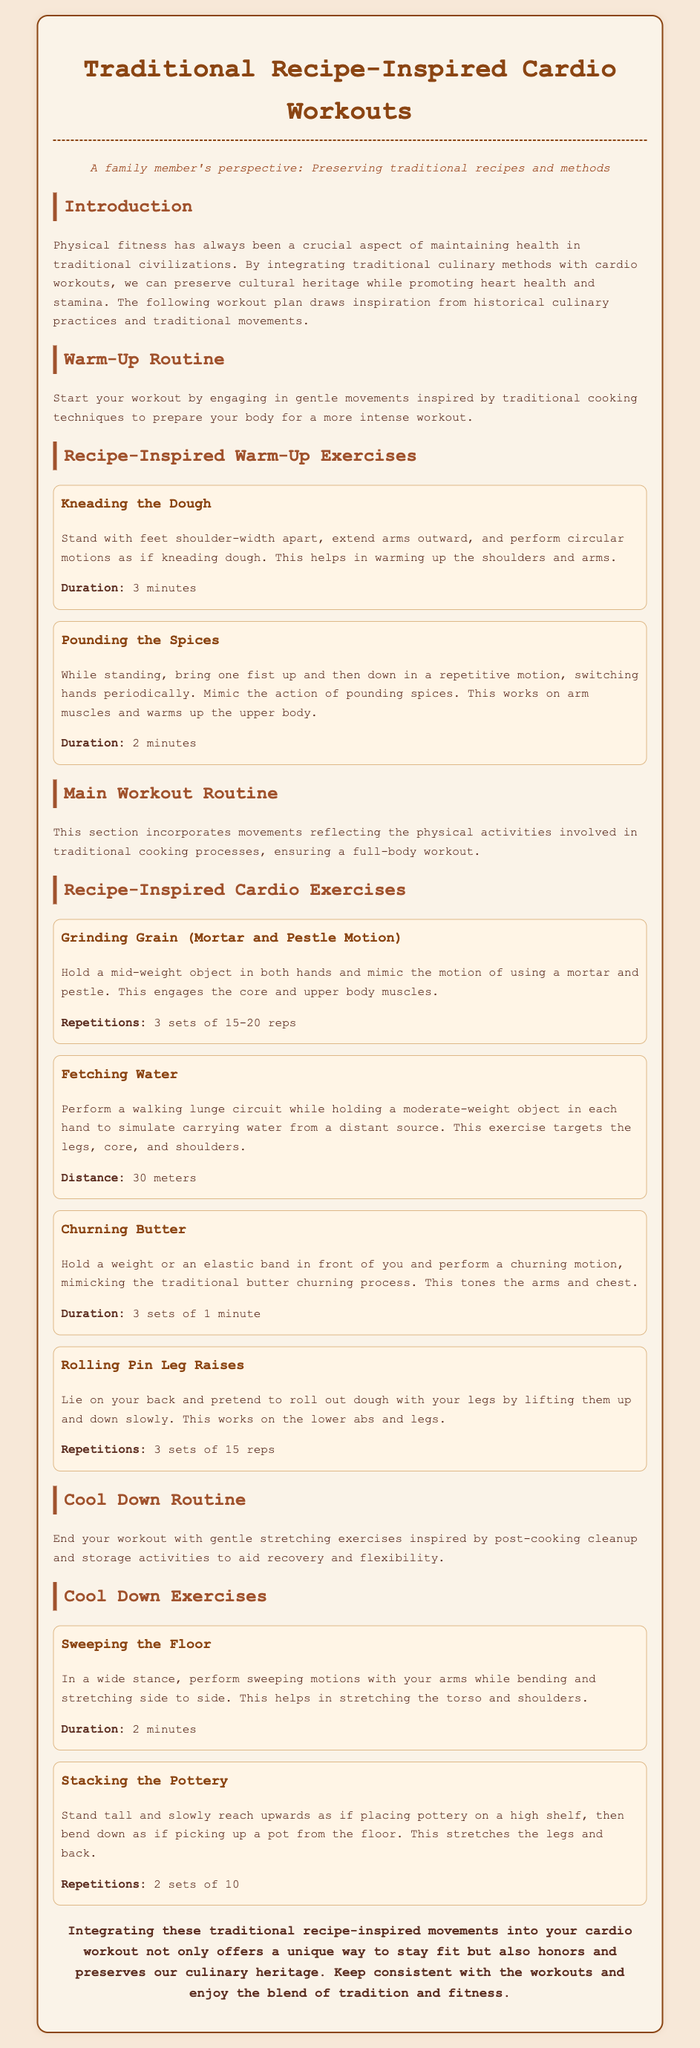What is the title of the document? The title is prominently displayed at the top of the document, indicating the main topic.
Answer: Traditional Recipe-Inspired Cardio Workouts How long should the "Kneading the Dough" exercise be performed? The duration of this exercise is specifically mentioned under its description.
Answer: 3 minutes What is the main focus of this workout plan? The introduction explains the purpose and focus of the workout plan reflecting traditional practices.
Answer: Preserving cultural heritage while promoting heart health What exercise involves mimicking the action of using a mortar and pestle? The document provides specific names for each exercise that relate to cooking activities.
Answer: Grinding Grain (Mortar and Pestle Motion) How many repetitions are suggested for the "Rolling Pin Leg Raises"? The number of repetitions is detailed in the main workout routine for this exercise.
Answer: 3 sets of 15 reps What is the duration for the "Sweeping the Floor" cool down exercise? The duration is indicated specifically within the cool down exercises section of the document.
Answer: 2 minutes What action does the "Fetching Water" exercise simulate? The description explains that this exercise mimics a particular traditional task.
Answer: Carrying water from a distant source What is the final noted advice in the conclusion? The conclusion summarizes the overall message of the document, emphasizing a key piece of advice.
Answer: Keep consistent with the workouts 